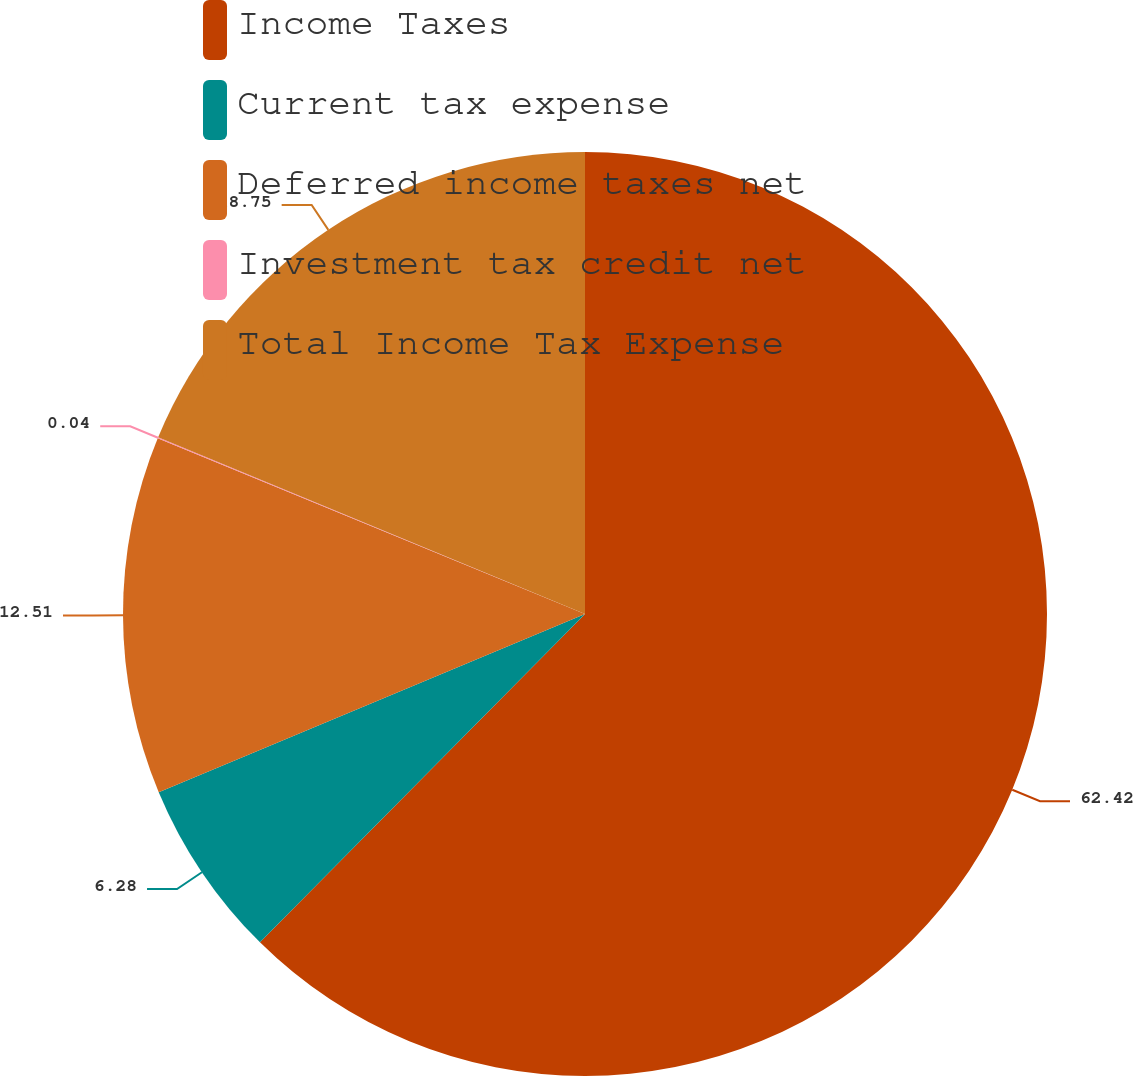Convert chart. <chart><loc_0><loc_0><loc_500><loc_500><pie_chart><fcel>Income Taxes<fcel>Current tax expense<fcel>Deferred income taxes net<fcel>Investment tax credit net<fcel>Total Income Tax Expense<nl><fcel>62.42%<fcel>6.28%<fcel>12.51%<fcel>0.04%<fcel>18.75%<nl></chart> 